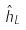Convert formula to latex. <formula><loc_0><loc_0><loc_500><loc_500>\hat { h } _ { L }</formula> 